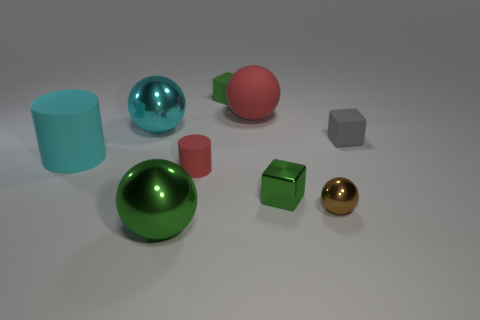How many green cubes must be subtracted to get 1 green cubes? 1 Subtract all big spheres. How many spheres are left? 1 Add 1 blue rubber cylinders. How many objects exist? 10 Subtract all gray spheres. Subtract all brown cylinders. How many spheres are left? 4 Subtract all balls. How many objects are left? 5 Add 6 red matte spheres. How many red matte spheres exist? 7 Subtract 0 yellow cylinders. How many objects are left? 9 Subtract all small green matte objects. Subtract all cyan shiny objects. How many objects are left? 7 Add 5 tiny gray objects. How many tiny gray objects are left? 6 